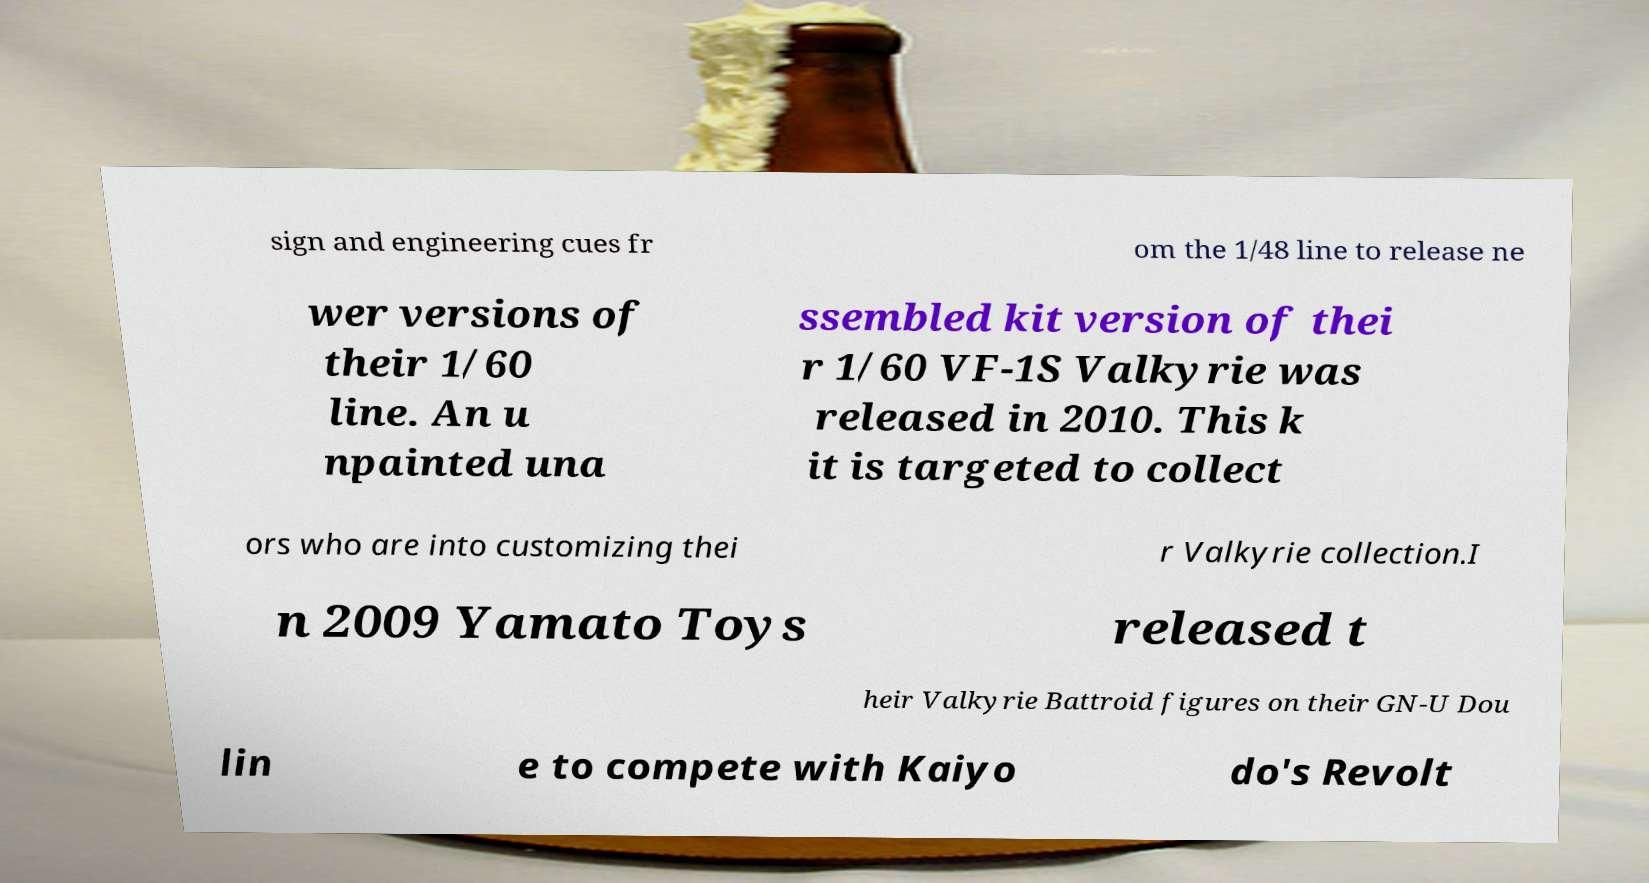Please read and relay the text visible in this image. What does it say? sign and engineering cues fr om the 1/48 line to release ne wer versions of their 1/60 line. An u npainted una ssembled kit version of thei r 1/60 VF-1S Valkyrie was released in 2010. This k it is targeted to collect ors who are into customizing thei r Valkyrie collection.I n 2009 Yamato Toys released t heir Valkyrie Battroid figures on their GN-U Dou lin e to compete with Kaiyo do's Revolt 